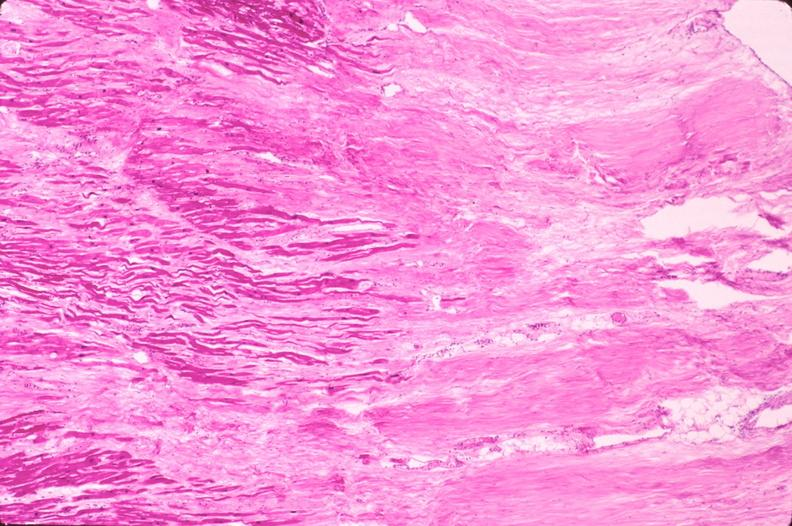what does this image show?
Answer the question using a single word or phrase. Heart 